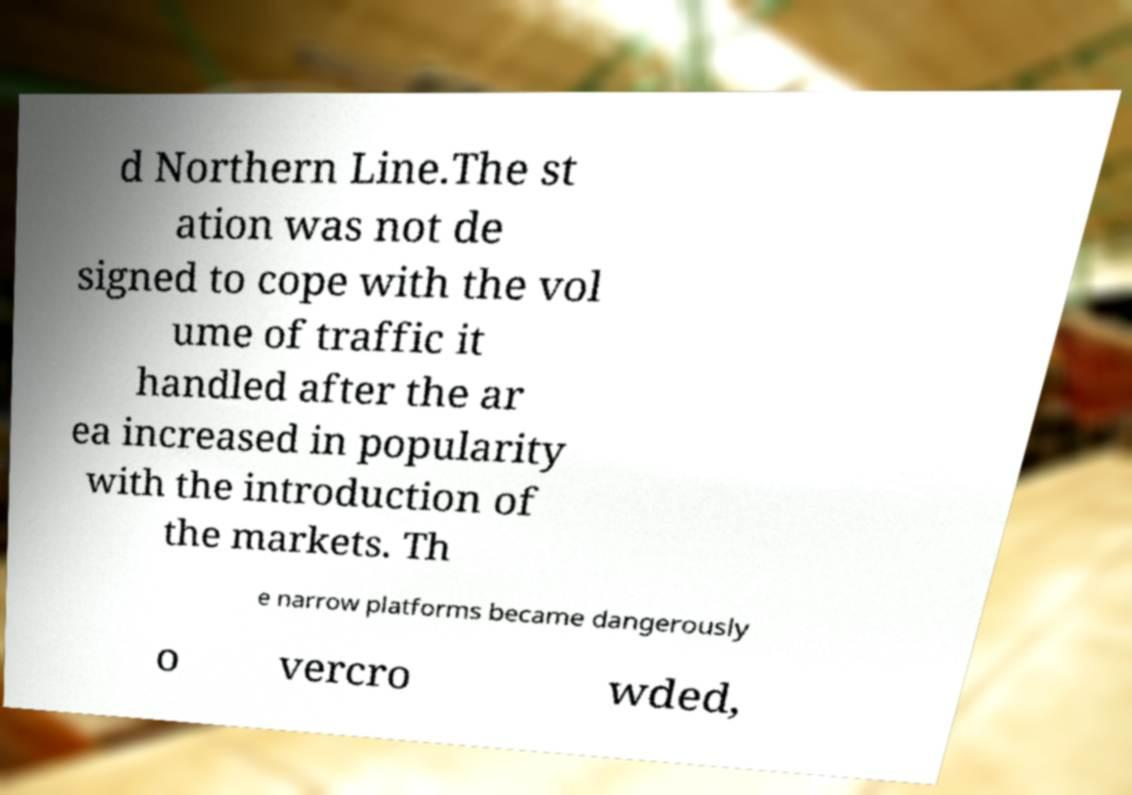Could you assist in decoding the text presented in this image and type it out clearly? d Northern Line.The st ation was not de signed to cope with the vol ume of traffic it handled after the ar ea increased in popularity with the introduction of the markets. Th e narrow platforms became dangerously o vercro wded, 